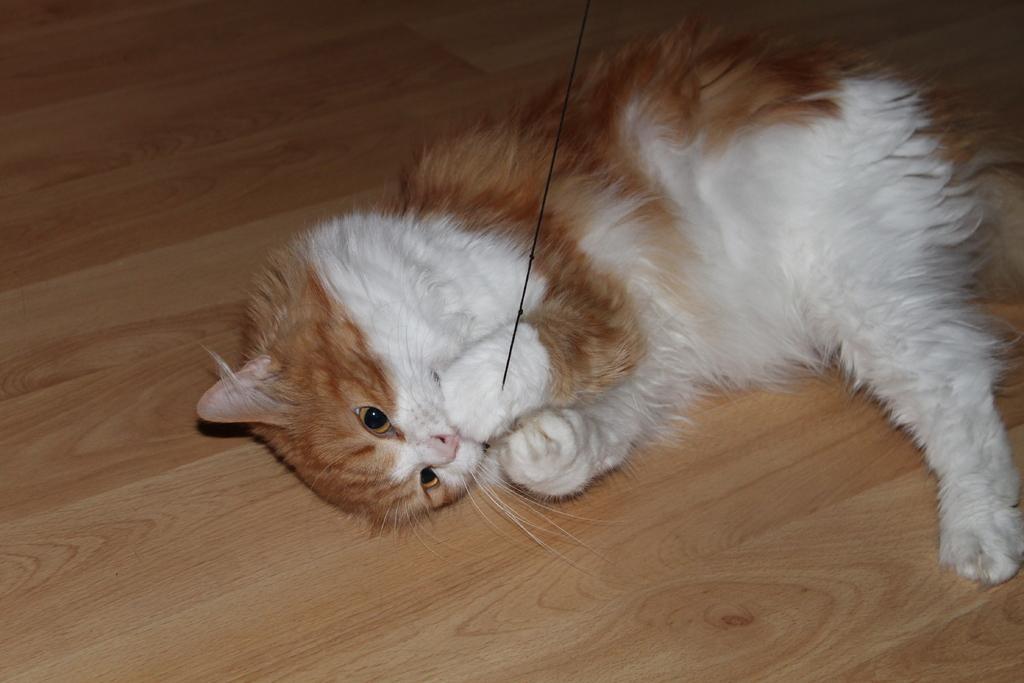How would you summarize this image in a sentence or two? In this image we can see a cat on the surface and the cat is holding a thread. 